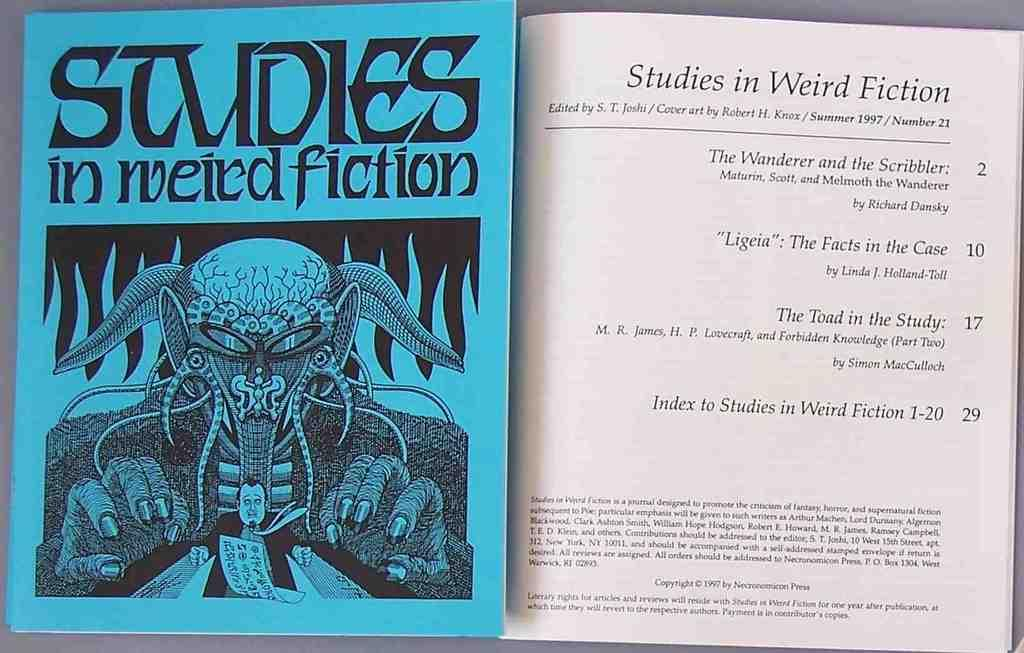<image>
Render a clear and concise summary of the photo. The book Studies in Weird Fiction was edited by S. T. Joshi 